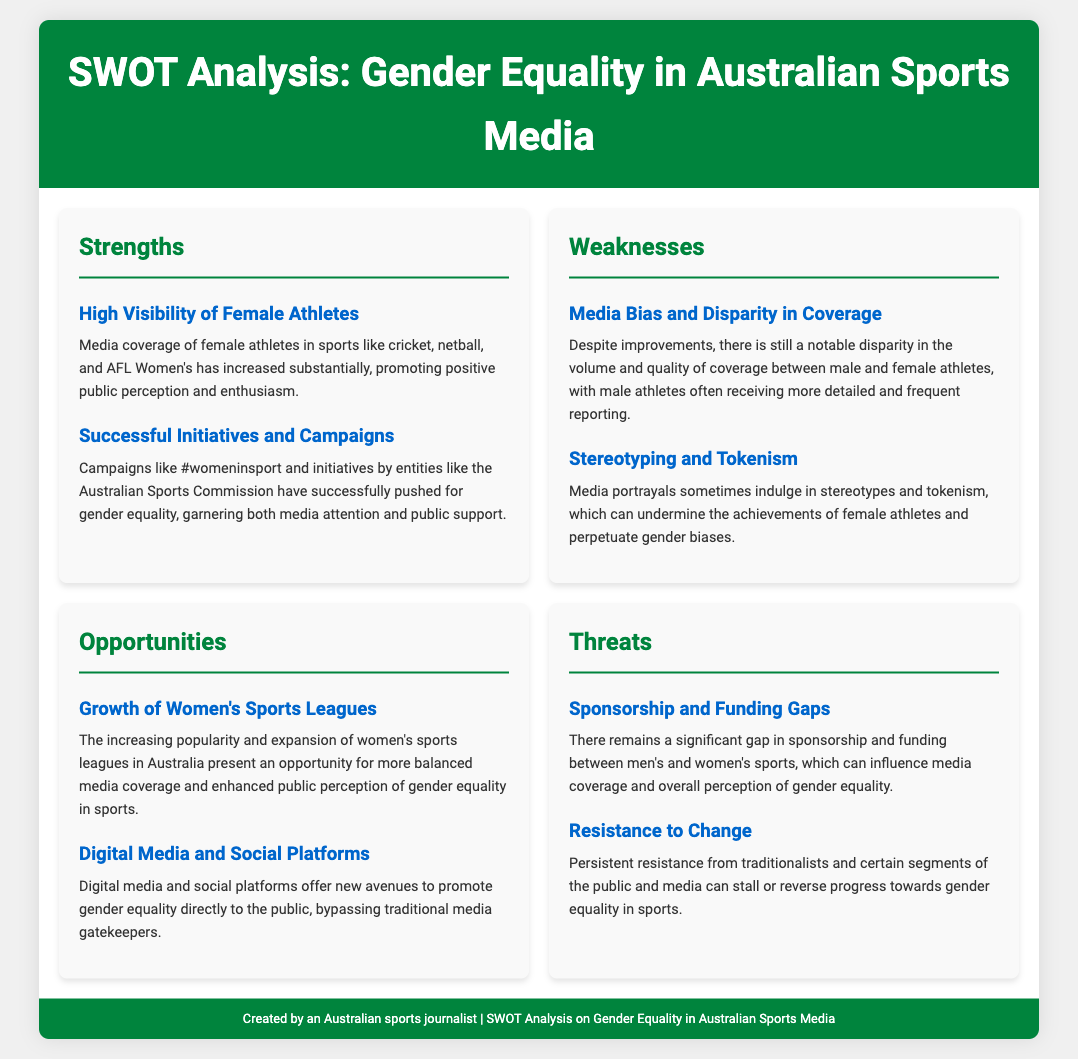What is the title of the document? The title of the document is shown in the header of the page, which displays the topic of the analysis.
Answer: SWOT Analysis: Gender Equality in Australian Sports Media What is one strength identified in the analysis? The strengths section lists examples that contribute positively to the media coverage of gender equality.
Answer: High Visibility of Female Athletes What campaign is mentioned as a successful initiative? The document provides a specific campaign that has effectively advocated for gender equality in sports.
Answer: #womeninsport What is a weakness related to media coverage? The weaknesses section discusses challenges faced in achieving equality in sports media representation.
Answer: Media Bias and Disparity in Coverage Name one opportunity identified for improving coverage. The opportunities section outlines prospects that could enhance gender equality discussions in sports media.
Answer: Growth of Women's Sports Leagues What is a threat posed to gender equality in sports? The threats section highlights ongoing challenges that may hinder progress in achieving gender equality.
Answer: Sponsorship and Funding Gaps What does the document mention about traditional media? The analysis discusses the role of traditional media in relation to gender equality initiatives.
Answer: Resistance to Change How many strengths are listed in the SWOT analysis? The strengths section contains a count of the specific strengths identified in the analysis.
Answer: Two 